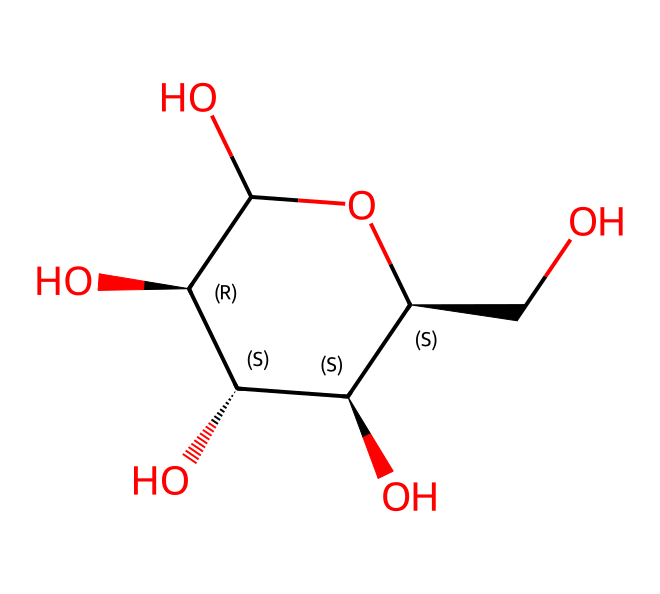What is the molecular formula of this chemical? The SMILES structure indicates there are six carbon atoms (C), twelve hydrogen atoms (H), and six oxygen atoms (O) present in the molecule, leading to the formula C6H12O6.
Answer: C6H12O6 How many chiral centers are present in this molecule? By analyzing the structure, it can be seen that there are four carbon atoms (C) that are bonded to four different substituents, indicating that these atoms are chiral centers.
Answer: 4 What type of chemical is represented by this SMILES? The structure contains multiple hydroxyl (–OH) groups and a cyclic carbohydrate structure, indicating that it is a carbohydrate, specifically a sugar or polysaccharide.
Answer: carbohydrate How many hydroxyl groups are in this chemical? Two oxygen atoms in the molecular structure are part of hydroxyl (–OH) groups, totaling five hydroxyl groups in the molecule.
Answer: 5 What is the primary function of this molecule in relation to paper? Cellulose serves as a structural component in plant cell walls, providing strength and rigidity, which is critical for the integrity of paper produced from wood fibers.
Answer: structure Is this molecule soluble in water? Cellulose does not dissolve in water but forms hydrogen bonds with water molecules, which allows water to interact with it despite not being soluble.
Answer: no 